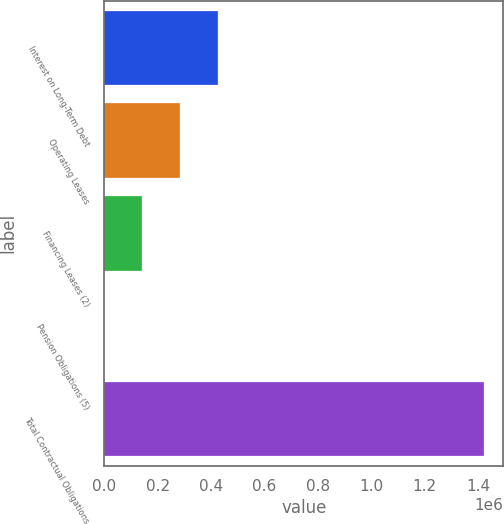<chart> <loc_0><loc_0><loc_500><loc_500><bar_chart><fcel>Interest on Long-Term Debt<fcel>Operating Leases<fcel>Financing Leases (2)<fcel>Pension Obligations (5)<fcel>Total Contractual Obligations<nl><fcel>427844<fcel>285483<fcel>143122<fcel>760<fcel>1.42438e+06<nl></chart> 